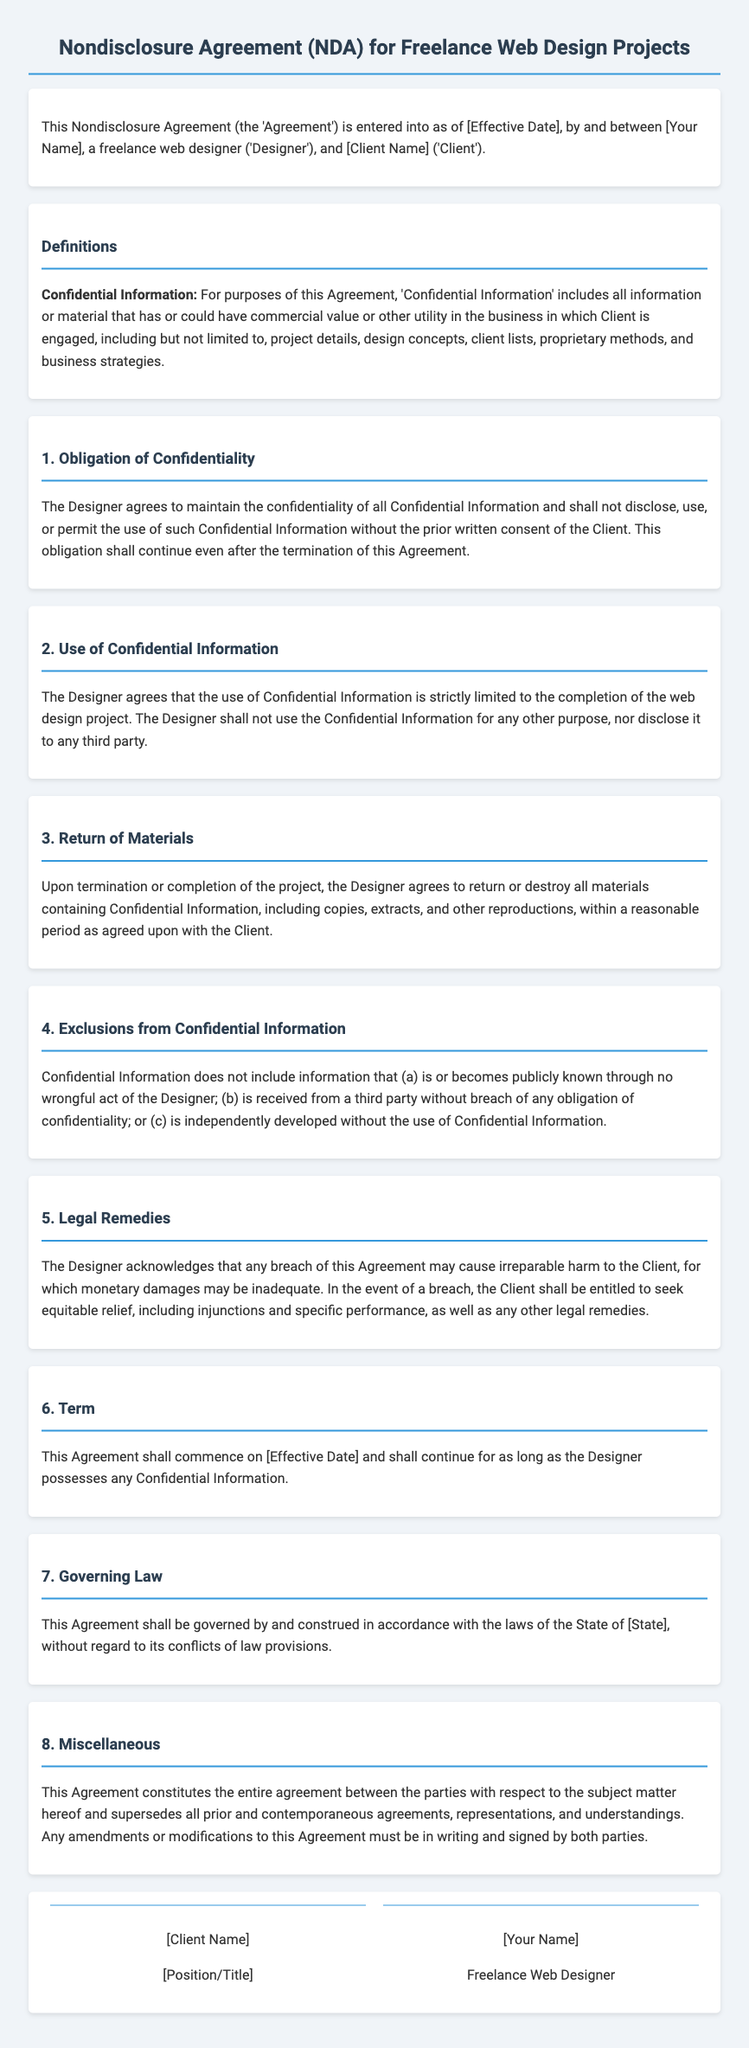What is the title of the document? The title is stated at the top of the document, which is a Nondisclosure Agreement for Freelance Web Design Projects.
Answer: Nondisclosure Agreement (NDA) for Freelance Web Design Projects Who are the parties involved in the agreement? The parties named at the beginning of the document are the Designer and the Client.
Answer: [Your Name] and [Client Name] What is considered 'Confidential Information'? This definition is provided in the section titled "Definitions," specifically outlining what constitutes Confidential Information.
Answer: Project details, design concepts, client lists, proprietary methods, and business strategies What must the Designer do with Confidential Information post-project? This information is mentioned in the "Return of Materials" clause detailing what the Designer is obligated to do.
Answer: Return or destroy all materials containing Confidential Information What happens in case of a breach of the agreement? The "Legal Remedies" section elaborates on the actions the Client can take if the Designer breaches the agreement.
Answer: Seek equitable relief, including injunctions and specific performance How long does the agreement last? The duration of the agreement is specified in the "Term" clause.
Answer: For as long as the Designer possesses any Confidential Information What law governs this agreement? The "Governing Law" clause indicates which state's laws apply to the agreement.
Answer: The laws of the State of [State] What is required for amendments to the agreement? The "Miscellaneous" section specifies the necessary condition for modifications to be valid.
Answer: Written and signed by both parties 